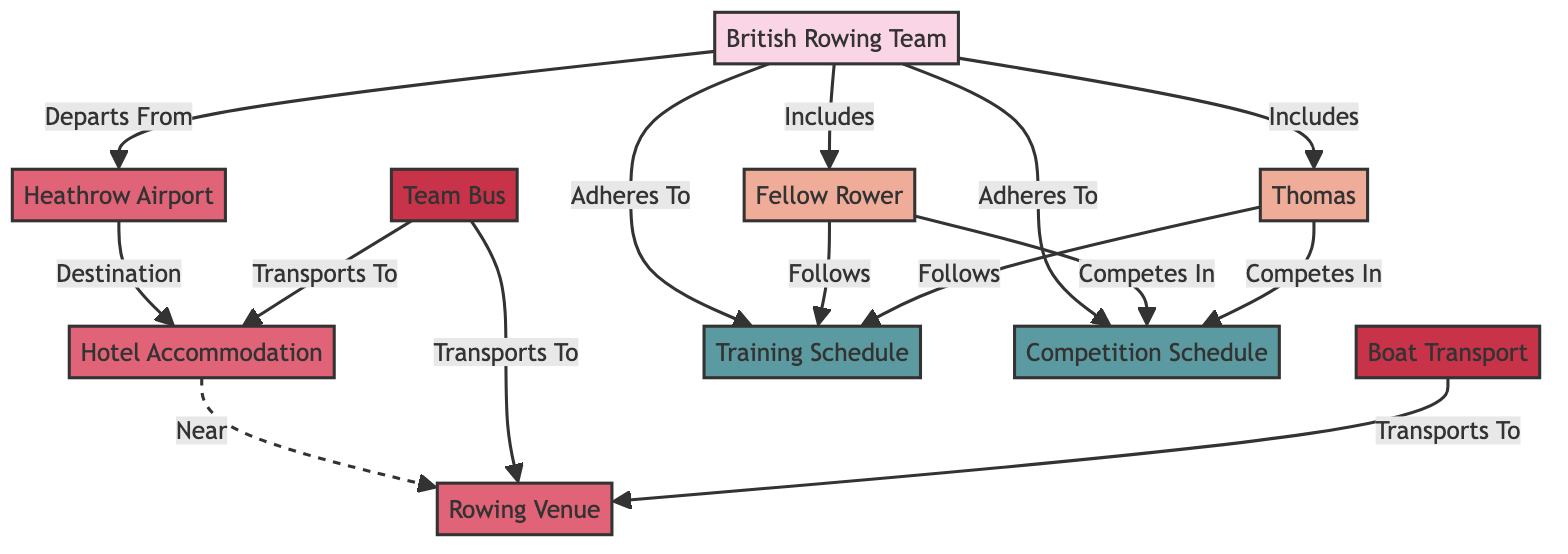What's the total number of nodes in the diagram? The diagram consists of entities, persons, locations, transports, and schedules. By counting each node listed, there are a total of 10 nodes in the diagram.
Answer: 10 Which person competes in the competition schedule? Both Thomas and Fellow Rower are identified as persons who compete in the competition schedule, as indicated by the connection from each to the competition schedule node.
Answer: Thomas, Fellow Rower What location does the British Rowing Team depart from? The diagram shows an edge from the British Rowing Team to Heathrow Airport, indicating that it is the location they depart from.
Answer: Heathrow Airport How many types of transport are mentioned in the diagram? There are two types of transport mentioned: Team Bus and Boat Transport. Each of these is a node in the diagram connected to relevant locations.
Answer: 2 Which location is near the Hotel Accommodation? The rowing venue is indicated as being near the Hotel Accommodation, as shown by the dashed connection representing proximity in the diagram.
Answer: Rowing Venue What does the Fellow Rower follow? According to the diagram, the Fellow Rower follows the Training Schedule, which is specifically indicated by an edge between Fellow Rower and Training Schedule.
Answer: Training Schedule What is the destination after departing from Heathrow Airport? The diagram indicates that the destination after departing from Heathrow Airport is Hotel Accommodation, as shown by the directed edge between them.
Answer: Hotel Accommodation Which transport option is used to transport to both the Hotel Accommodation and the Rowing Venue? The Team Bus is responsible for transporting to both Hotel Accommodation and Rowing Venue, as indicated by the edges from Team Bus to these two locations.
Answer: Team Bus What schedules does the British Rowing Team adhere to? The British Rowing Team adheres to both the Training Schedule and the Competition Schedule, as indicated by the edges connecting them to these two schedule nodes.
Answer: Training Schedule, Competition Schedule 